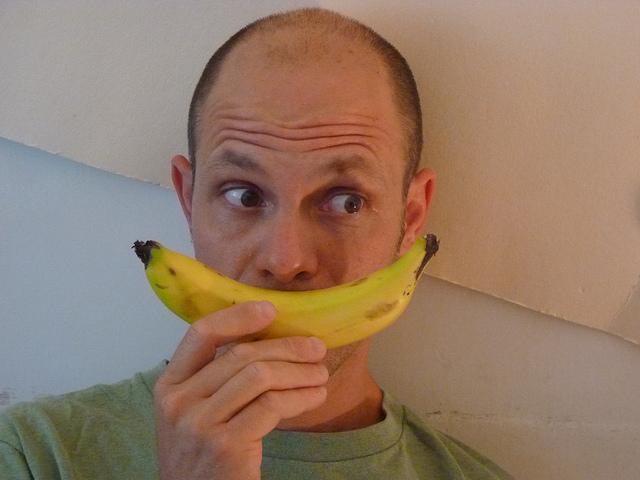Can the man use the banana as a mustache?
Be succinct. No. Has this banana been peeled?
Answer briefly. No. What color is his shirt?
Concise answer only. Green. IS this man's eyes open?
Be succinct. Yes. 